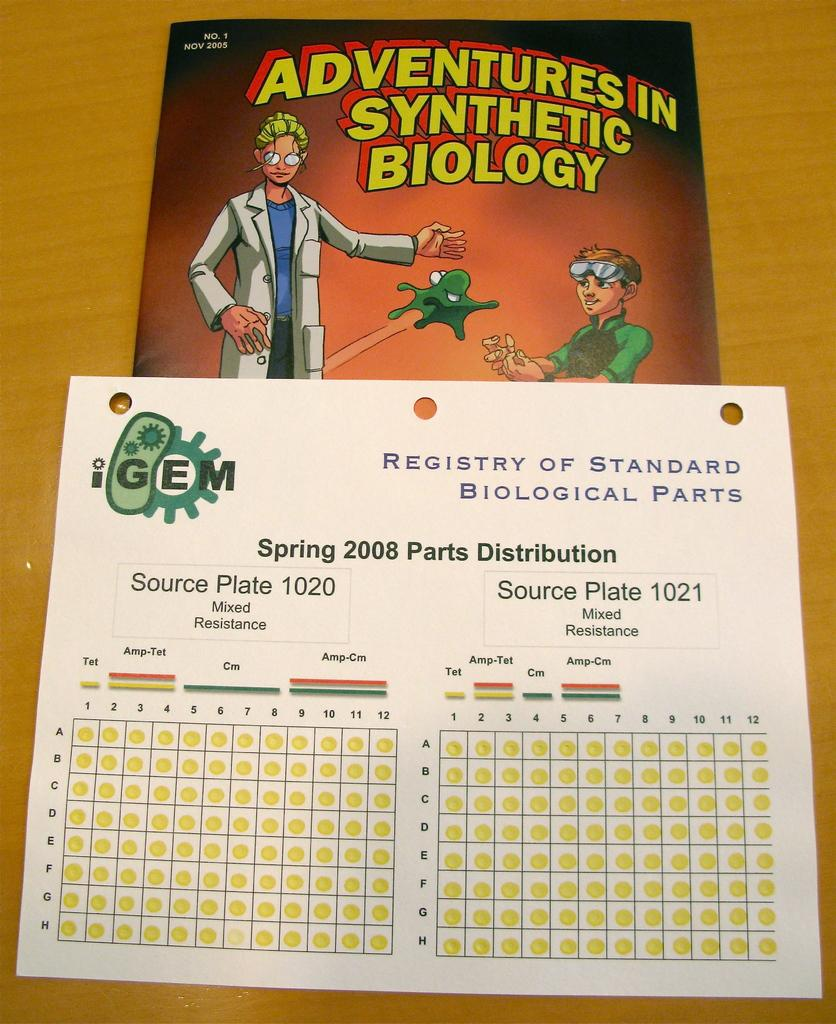<image>
Provide a brief description of the given image. A textbook titled Adventures in Synthetic Biology from November 2009. 